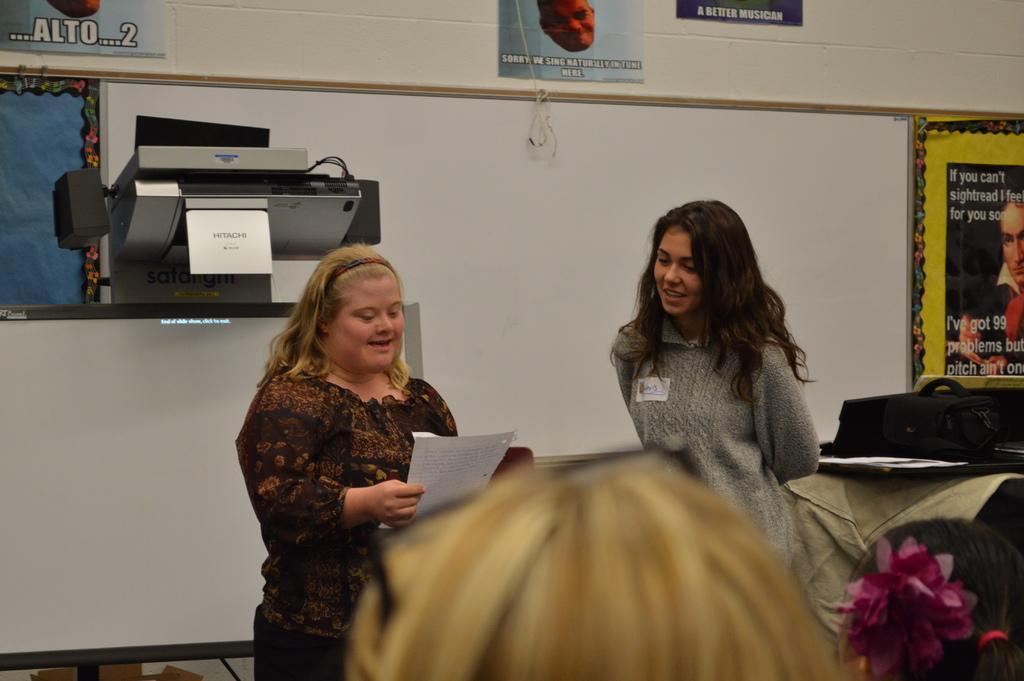In one or two sentences, can you explain what this image depicts? In the image in the center we can see two persons were standing and they were smiling,which we can see on their faces. And the left person is holding paper. In the bottom of the image we can see one person head. In the background there is a wall,posters,machine,board,banners,papers,cloth,plastic flower and few other objects. 